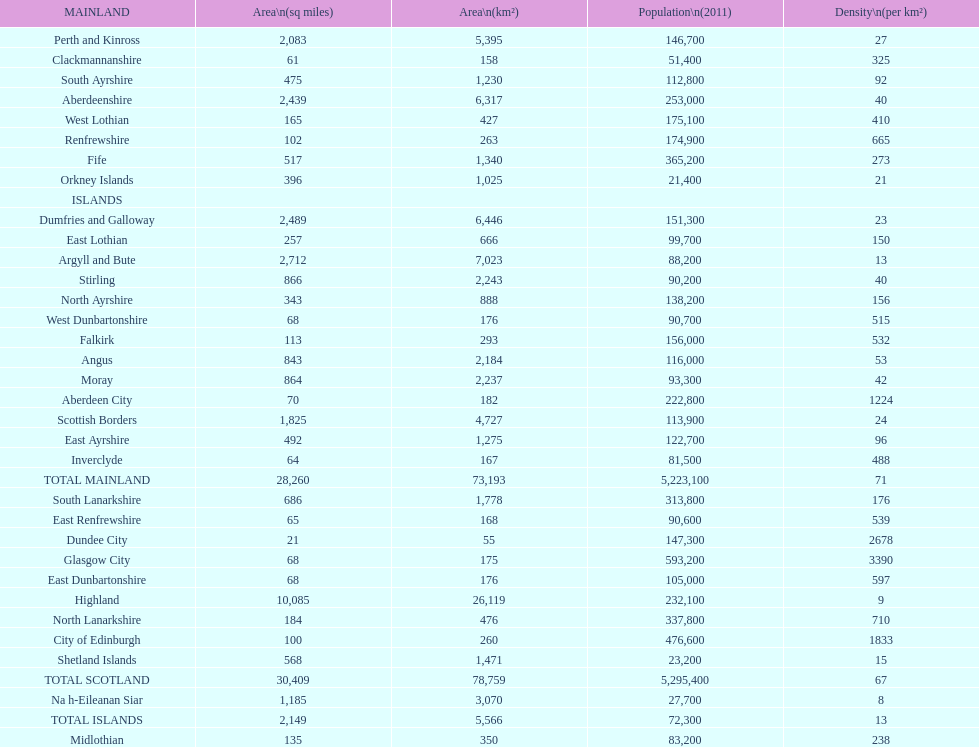Which is the only subdivision to have a greater area than argyll and bute? Highland. 